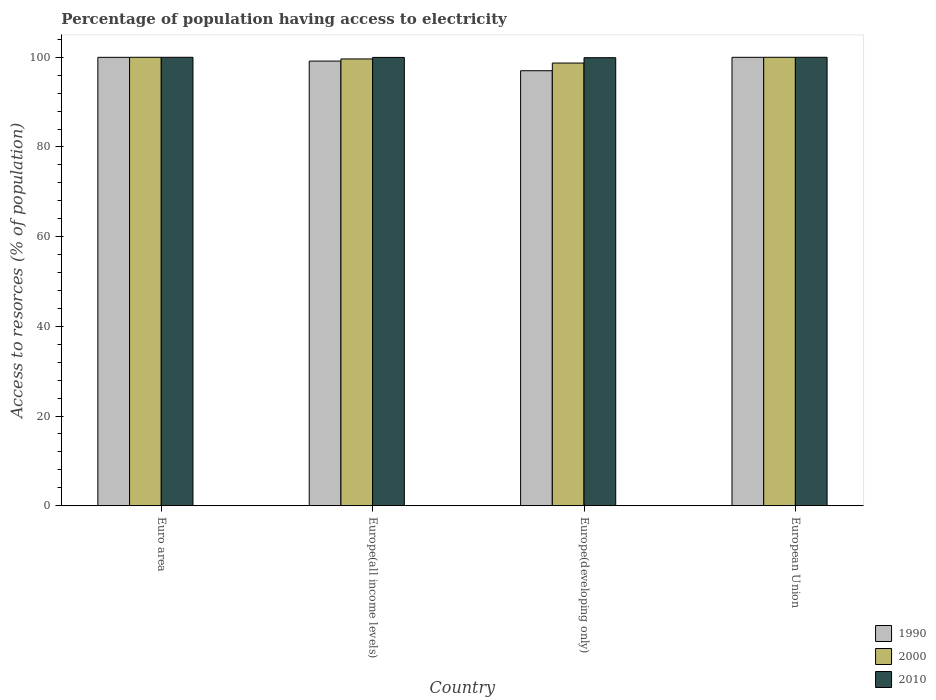How many groups of bars are there?
Provide a short and direct response. 4. Are the number of bars per tick equal to the number of legend labels?
Your answer should be very brief. Yes. Are the number of bars on each tick of the X-axis equal?
Ensure brevity in your answer.  Yes. How many bars are there on the 3rd tick from the left?
Ensure brevity in your answer.  3. In how many cases, is the number of bars for a given country not equal to the number of legend labels?
Provide a short and direct response. 0. What is the percentage of population having access to electricity in 1990 in Europe(all income levels)?
Give a very brief answer. 99.15. Across all countries, what is the maximum percentage of population having access to electricity in 2000?
Your answer should be very brief. 100. Across all countries, what is the minimum percentage of population having access to electricity in 2010?
Keep it short and to the point. 99.91. In which country was the percentage of population having access to electricity in 2010 minimum?
Offer a terse response. Europe(developing only). What is the total percentage of population having access to electricity in 1990 in the graph?
Offer a terse response. 396.14. What is the difference between the percentage of population having access to electricity in 2000 in Europe(developing only) and that in European Union?
Offer a terse response. -1.28. What is the difference between the percentage of population having access to electricity in 1990 in Europe(developing only) and the percentage of population having access to electricity in 2010 in Europe(all income levels)?
Keep it short and to the point. -2.97. What is the average percentage of population having access to electricity in 1990 per country?
Your answer should be very brief. 99.04. What is the ratio of the percentage of population having access to electricity in 2010 in Europe(all income levels) to that in European Union?
Provide a short and direct response. 1. Is the percentage of population having access to electricity in 2000 in Europe(all income levels) less than that in Europe(developing only)?
Provide a succinct answer. No. Is the difference between the percentage of population having access to electricity in 2000 in Euro area and Europe(all income levels) greater than the difference between the percentage of population having access to electricity in 2010 in Euro area and Europe(all income levels)?
Give a very brief answer. Yes. What is the difference between the highest and the second highest percentage of population having access to electricity in 2010?
Provide a short and direct response. -0.03. What is the difference between the highest and the lowest percentage of population having access to electricity in 1990?
Give a very brief answer. 2.99. Is the sum of the percentage of population having access to electricity in 2010 in Euro area and Europe(all income levels) greater than the maximum percentage of population having access to electricity in 1990 across all countries?
Your answer should be compact. Yes. What does the 1st bar from the left in Europe(all income levels) represents?
Provide a succinct answer. 1990. What does the 3rd bar from the right in European Union represents?
Offer a very short reply. 1990. Is it the case that in every country, the sum of the percentage of population having access to electricity in 1990 and percentage of population having access to electricity in 2010 is greater than the percentage of population having access to electricity in 2000?
Ensure brevity in your answer.  Yes. How many countries are there in the graph?
Provide a short and direct response. 4. What is the difference between two consecutive major ticks on the Y-axis?
Your response must be concise. 20. Are the values on the major ticks of Y-axis written in scientific E-notation?
Make the answer very short. No. Does the graph contain any zero values?
Make the answer very short. No. Does the graph contain grids?
Your answer should be compact. No. Where does the legend appear in the graph?
Offer a very short reply. Bottom right. How many legend labels are there?
Offer a very short reply. 3. What is the title of the graph?
Your response must be concise. Percentage of population having access to electricity. Does "1992" appear as one of the legend labels in the graph?
Offer a terse response. No. What is the label or title of the X-axis?
Offer a terse response. Country. What is the label or title of the Y-axis?
Make the answer very short. Access to resorces (% of population). What is the Access to resorces (% of population) of 1990 in Euro area?
Your response must be concise. 99.99. What is the Access to resorces (% of population) of 2010 in Euro area?
Make the answer very short. 100. What is the Access to resorces (% of population) of 1990 in Europe(all income levels)?
Your answer should be very brief. 99.15. What is the Access to resorces (% of population) in 2000 in Europe(all income levels)?
Your answer should be compact. 99.63. What is the Access to resorces (% of population) of 2010 in Europe(all income levels)?
Make the answer very short. 99.97. What is the Access to resorces (% of population) of 1990 in Europe(developing only)?
Provide a short and direct response. 97. What is the Access to resorces (% of population) of 2000 in Europe(developing only)?
Provide a succinct answer. 98.72. What is the Access to resorces (% of population) in 2010 in Europe(developing only)?
Your response must be concise. 99.91. What is the Access to resorces (% of population) of 1990 in European Union?
Your response must be concise. 99.99. What is the Access to resorces (% of population) of 2010 in European Union?
Your answer should be very brief. 100. Across all countries, what is the maximum Access to resorces (% of population) of 1990?
Provide a succinct answer. 99.99. Across all countries, what is the minimum Access to resorces (% of population) in 1990?
Ensure brevity in your answer.  97. Across all countries, what is the minimum Access to resorces (% of population) of 2000?
Offer a very short reply. 98.72. Across all countries, what is the minimum Access to resorces (% of population) of 2010?
Your response must be concise. 99.91. What is the total Access to resorces (% of population) in 1990 in the graph?
Your response must be concise. 396.14. What is the total Access to resorces (% of population) of 2000 in the graph?
Provide a short and direct response. 398.35. What is the total Access to resorces (% of population) of 2010 in the graph?
Make the answer very short. 399.89. What is the difference between the Access to resorces (% of population) in 1990 in Euro area and that in Europe(all income levels)?
Offer a very short reply. 0.84. What is the difference between the Access to resorces (% of population) in 2000 in Euro area and that in Europe(all income levels)?
Give a very brief answer. 0.37. What is the difference between the Access to resorces (% of population) in 2010 in Euro area and that in Europe(all income levels)?
Provide a succinct answer. 0.03. What is the difference between the Access to resorces (% of population) in 1990 in Euro area and that in Europe(developing only)?
Offer a terse response. 2.99. What is the difference between the Access to resorces (% of population) of 2000 in Euro area and that in Europe(developing only)?
Make the answer very short. 1.28. What is the difference between the Access to resorces (% of population) of 2010 in Euro area and that in Europe(developing only)?
Keep it short and to the point. 0.09. What is the difference between the Access to resorces (% of population) in 1990 in Euro area and that in European Union?
Provide a succinct answer. -0. What is the difference between the Access to resorces (% of population) in 2000 in Euro area and that in European Union?
Ensure brevity in your answer.  0. What is the difference between the Access to resorces (% of population) of 2010 in Euro area and that in European Union?
Your answer should be very brief. 0. What is the difference between the Access to resorces (% of population) in 1990 in Europe(all income levels) and that in Europe(developing only)?
Give a very brief answer. 2.15. What is the difference between the Access to resorces (% of population) of 2000 in Europe(all income levels) and that in Europe(developing only)?
Give a very brief answer. 0.92. What is the difference between the Access to resorces (% of population) in 2010 in Europe(all income levels) and that in Europe(developing only)?
Give a very brief answer. 0.06. What is the difference between the Access to resorces (% of population) of 1990 in Europe(all income levels) and that in European Union?
Give a very brief answer. -0.84. What is the difference between the Access to resorces (% of population) in 2000 in Europe(all income levels) and that in European Union?
Your answer should be compact. -0.37. What is the difference between the Access to resorces (% of population) in 2010 in Europe(all income levels) and that in European Union?
Offer a very short reply. -0.03. What is the difference between the Access to resorces (% of population) in 1990 in Europe(developing only) and that in European Union?
Ensure brevity in your answer.  -2.99. What is the difference between the Access to resorces (% of population) in 2000 in Europe(developing only) and that in European Union?
Give a very brief answer. -1.28. What is the difference between the Access to resorces (% of population) of 2010 in Europe(developing only) and that in European Union?
Keep it short and to the point. -0.09. What is the difference between the Access to resorces (% of population) in 1990 in Euro area and the Access to resorces (% of population) in 2000 in Europe(all income levels)?
Provide a succinct answer. 0.36. What is the difference between the Access to resorces (% of population) of 1990 in Euro area and the Access to resorces (% of population) of 2010 in Europe(all income levels)?
Keep it short and to the point. 0.02. What is the difference between the Access to resorces (% of population) in 2000 in Euro area and the Access to resorces (% of population) in 2010 in Europe(all income levels)?
Offer a terse response. 0.03. What is the difference between the Access to resorces (% of population) in 1990 in Euro area and the Access to resorces (% of population) in 2000 in Europe(developing only)?
Provide a short and direct response. 1.28. What is the difference between the Access to resorces (% of population) of 1990 in Euro area and the Access to resorces (% of population) of 2010 in Europe(developing only)?
Offer a very short reply. 0.08. What is the difference between the Access to resorces (% of population) of 2000 in Euro area and the Access to resorces (% of population) of 2010 in Europe(developing only)?
Give a very brief answer. 0.09. What is the difference between the Access to resorces (% of population) of 1990 in Euro area and the Access to resorces (% of population) of 2000 in European Union?
Offer a terse response. -0.01. What is the difference between the Access to resorces (% of population) in 1990 in Euro area and the Access to resorces (% of population) in 2010 in European Union?
Provide a short and direct response. -0.01. What is the difference between the Access to resorces (% of population) of 1990 in Europe(all income levels) and the Access to resorces (% of population) of 2000 in Europe(developing only)?
Provide a short and direct response. 0.44. What is the difference between the Access to resorces (% of population) in 1990 in Europe(all income levels) and the Access to resorces (% of population) in 2010 in Europe(developing only)?
Your answer should be compact. -0.76. What is the difference between the Access to resorces (% of population) in 2000 in Europe(all income levels) and the Access to resorces (% of population) in 2010 in Europe(developing only)?
Your response must be concise. -0.28. What is the difference between the Access to resorces (% of population) in 1990 in Europe(all income levels) and the Access to resorces (% of population) in 2000 in European Union?
Your answer should be compact. -0.85. What is the difference between the Access to resorces (% of population) of 1990 in Europe(all income levels) and the Access to resorces (% of population) of 2010 in European Union?
Give a very brief answer. -0.85. What is the difference between the Access to resorces (% of population) in 2000 in Europe(all income levels) and the Access to resorces (% of population) in 2010 in European Union?
Your response must be concise. -0.37. What is the difference between the Access to resorces (% of population) in 1990 in Europe(developing only) and the Access to resorces (% of population) in 2000 in European Union?
Offer a terse response. -3. What is the difference between the Access to resorces (% of population) in 1990 in Europe(developing only) and the Access to resorces (% of population) in 2010 in European Union?
Offer a terse response. -3. What is the difference between the Access to resorces (% of population) in 2000 in Europe(developing only) and the Access to resorces (% of population) in 2010 in European Union?
Provide a short and direct response. -1.28. What is the average Access to resorces (% of population) in 1990 per country?
Provide a succinct answer. 99.04. What is the average Access to resorces (% of population) in 2000 per country?
Give a very brief answer. 99.59. What is the average Access to resorces (% of population) of 2010 per country?
Your answer should be very brief. 99.97. What is the difference between the Access to resorces (% of population) of 1990 and Access to resorces (% of population) of 2000 in Euro area?
Ensure brevity in your answer.  -0.01. What is the difference between the Access to resorces (% of population) of 1990 and Access to resorces (% of population) of 2010 in Euro area?
Your answer should be very brief. -0.01. What is the difference between the Access to resorces (% of population) of 2000 and Access to resorces (% of population) of 2010 in Euro area?
Ensure brevity in your answer.  0. What is the difference between the Access to resorces (% of population) of 1990 and Access to resorces (% of population) of 2000 in Europe(all income levels)?
Keep it short and to the point. -0.48. What is the difference between the Access to resorces (% of population) in 1990 and Access to resorces (% of population) in 2010 in Europe(all income levels)?
Ensure brevity in your answer.  -0.82. What is the difference between the Access to resorces (% of population) of 2000 and Access to resorces (% of population) of 2010 in Europe(all income levels)?
Offer a very short reply. -0.34. What is the difference between the Access to resorces (% of population) in 1990 and Access to resorces (% of population) in 2000 in Europe(developing only)?
Your answer should be compact. -1.71. What is the difference between the Access to resorces (% of population) in 1990 and Access to resorces (% of population) in 2010 in Europe(developing only)?
Make the answer very short. -2.91. What is the difference between the Access to resorces (% of population) of 2000 and Access to resorces (% of population) of 2010 in Europe(developing only)?
Your answer should be compact. -1.2. What is the difference between the Access to resorces (% of population) of 1990 and Access to resorces (% of population) of 2000 in European Union?
Your answer should be very brief. -0.01. What is the difference between the Access to resorces (% of population) in 1990 and Access to resorces (% of population) in 2010 in European Union?
Offer a terse response. -0.01. What is the difference between the Access to resorces (% of population) in 2000 and Access to resorces (% of population) in 2010 in European Union?
Your response must be concise. 0. What is the ratio of the Access to resorces (% of population) in 1990 in Euro area to that in Europe(all income levels)?
Your answer should be very brief. 1.01. What is the ratio of the Access to resorces (% of population) in 1990 in Euro area to that in Europe(developing only)?
Offer a very short reply. 1.03. What is the ratio of the Access to resorces (% of population) of 2000 in Euro area to that in Europe(developing only)?
Ensure brevity in your answer.  1.01. What is the ratio of the Access to resorces (% of population) in 2010 in Euro area to that in European Union?
Your answer should be compact. 1. What is the ratio of the Access to resorces (% of population) in 1990 in Europe(all income levels) to that in Europe(developing only)?
Your answer should be very brief. 1.02. What is the ratio of the Access to resorces (% of population) of 2000 in Europe(all income levels) to that in Europe(developing only)?
Your answer should be very brief. 1.01. What is the ratio of the Access to resorces (% of population) in 2000 in Europe(all income levels) to that in European Union?
Your answer should be compact. 1. What is the ratio of the Access to resorces (% of population) of 2010 in Europe(all income levels) to that in European Union?
Your answer should be very brief. 1. What is the ratio of the Access to resorces (% of population) of 1990 in Europe(developing only) to that in European Union?
Your answer should be very brief. 0.97. What is the ratio of the Access to resorces (% of population) in 2000 in Europe(developing only) to that in European Union?
Provide a succinct answer. 0.99. What is the ratio of the Access to resorces (% of population) in 2010 in Europe(developing only) to that in European Union?
Provide a succinct answer. 1. What is the difference between the highest and the second highest Access to resorces (% of population) in 1990?
Your answer should be compact. 0. What is the difference between the highest and the second highest Access to resorces (% of population) of 2000?
Your response must be concise. 0. What is the difference between the highest and the second highest Access to resorces (% of population) of 2010?
Your answer should be compact. 0. What is the difference between the highest and the lowest Access to resorces (% of population) in 1990?
Your response must be concise. 2.99. What is the difference between the highest and the lowest Access to resorces (% of population) of 2000?
Make the answer very short. 1.28. What is the difference between the highest and the lowest Access to resorces (% of population) of 2010?
Your answer should be compact. 0.09. 